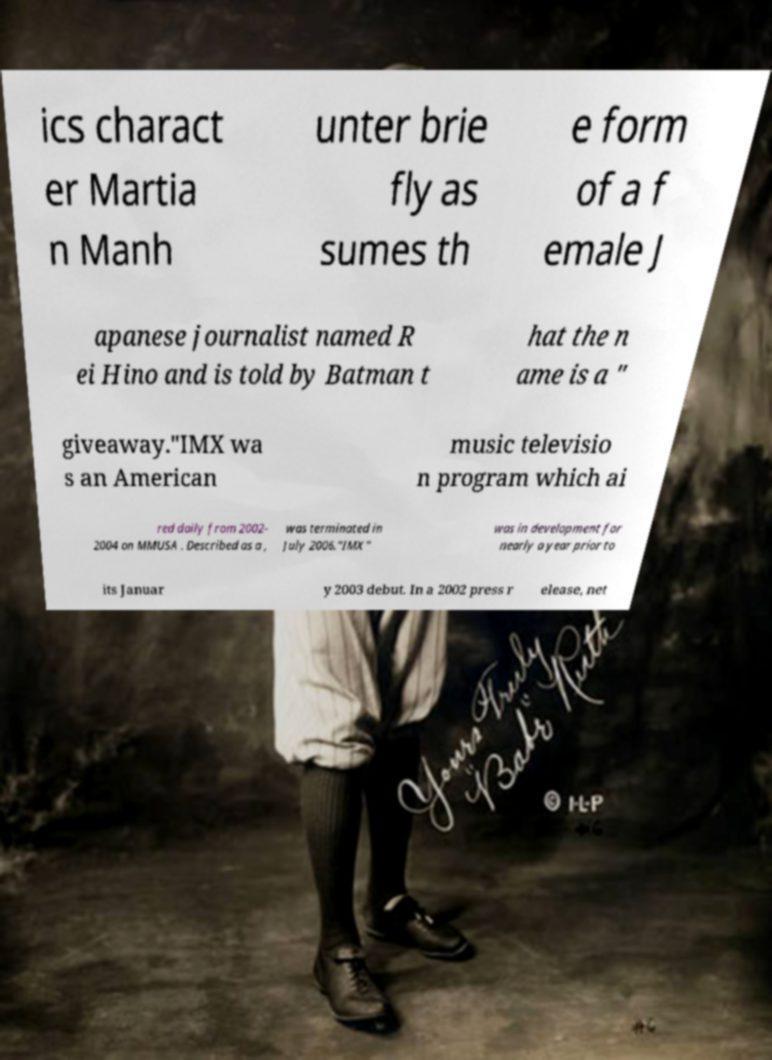I need the written content from this picture converted into text. Can you do that? ics charact er Martia n Manh unter brie fly as sumes th e form of a f emale J apanese journalist named R ei Hino and is told by Batman t hat the n ame is a " giveaway."IMX wa s an American music televisio n program which ai red daily from 2002- 2004 on MMUSA . Described as a , was terminated in July 2006."IMX" was in development for nearly a year prior to its Januar y 2003 debut. In a 2002 press r elease, net 